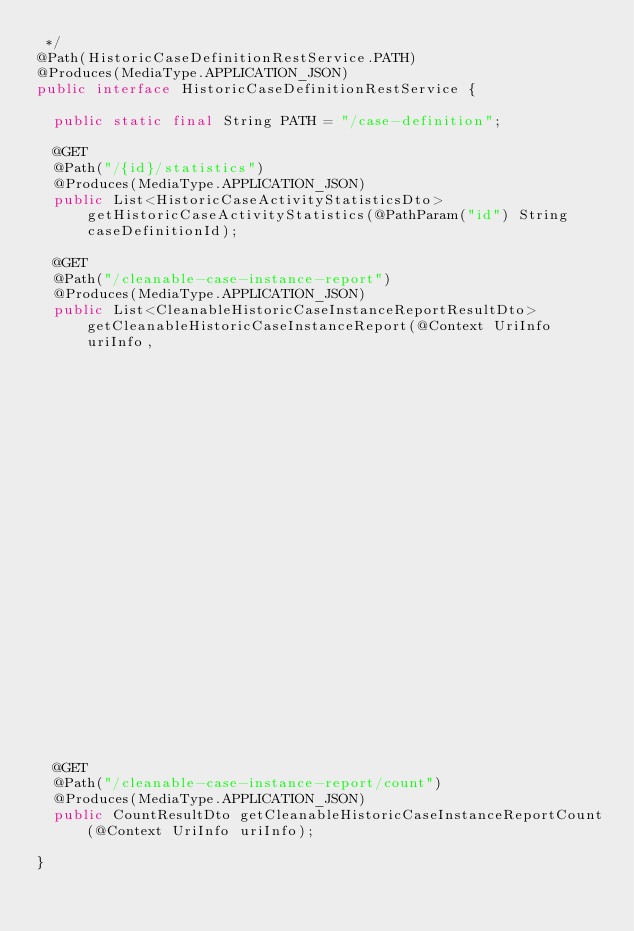<code> <loc_0><loc_0><loc_500><loc_500><_Java_> */
@Path(HistoricCaseDefinitionRestService.PATH)
@Produces(MediaType.APPLICATION_JSON)
public interface HistoricCaseDefinitionRestService {

  public static final String PATH = "/case-definition";

  @GET
  @Path("/{id}/statistics")
  @Produces(MediaType.APPLICATION_JSON)
  public List<HistoricCaseActivityStatisticsDto> getHistoricCaseActivityStatistics(@PathParam("id") String caseDefinitionId);

  @GET
  @Path("/cleanable-case-instance-report")
  @Produces(MediaType.APPLICATION_JSON)
  public List<CleanableHistoricCaseInstanceReportResultDto> getCleanableHistoricCaseInstanceReport(@Context UriInfo uriInfo,
                                                                                             @QueryParam("firstResult") Integer firstResult,
                                                                                             @QueryParam("maxResults") Integer maxResults);

  @GET
  @Path("/cleanable-case-instance-report/count")
  @Produces(MediaType.APPLICATION_JSON)
  public CountResultDto getCleanableHistoricCaseInstanceReportCount(@Context UriInfo uriInfo);

}
</code> 